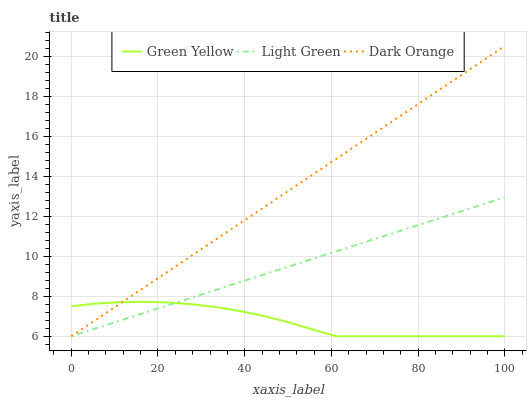Does Green Yellow have the minimum area under the curve?
Answer yes or no. Yes. Does Dark Orange have the maximum area under the curve?
Answer yes or no. Yes. Does Light Green have the minimum area under the curve?
Answer yes or no. No. Does Light Green have the maximum area under the curve?
Answer yes or no. No. Is Light Green the smoothest?
Answer yes or no. Yes. Is Green Yellow the roughest?
Answer yes or no. Yes. Is Green Yellow the smoothest?
Answer yes or no. No. Is Light Green the roughest?
Answer yes or no. No. Does Dark Orange have the lowest value?
Answer yes or no. Yes. Does Dark Orange have the highest value?
Answer yes or no. Yes. Does Light Green have the highest value?
Answer yes or no. No. Does Light Green intersect Green Yellow?
Answer yes or no. Yes. Is Light Green less than Green Yellow?
Answer yes or no. No. Is Light Green greater than Green Yellow?
Answer yes or no. No. 